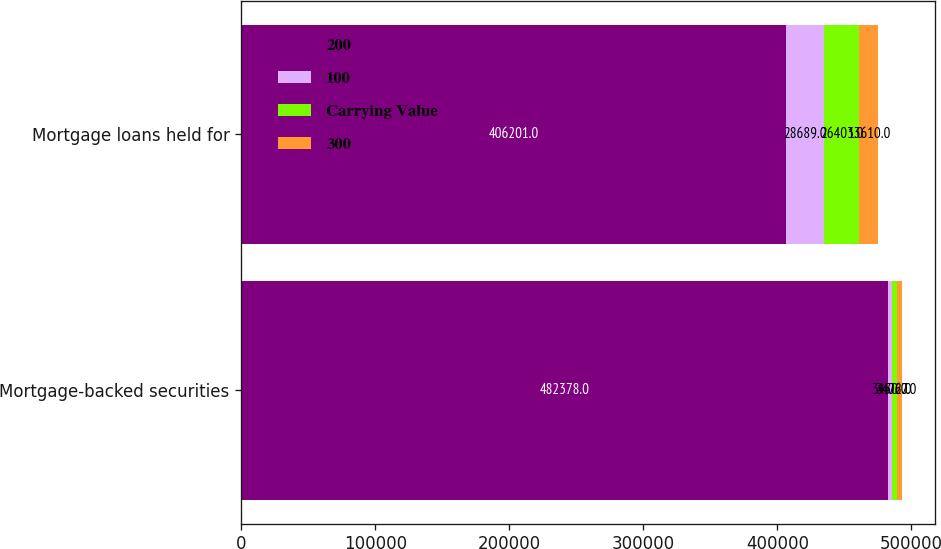Convert chart to OTSL. <chart><loc_0><loc_0><loc_500><loc_500><stacked_bar_chart><ecel><fcel>Mortgage-backed securities<fcel>Mortgage loans held for<nl><fcel>200<fcel>482378<fcel>406201<nl><fcel>100<fcel>3450<fcel>28689<nl><fcel>Carrying Value<fcel>3472<fcel>26403<nl><fcel>300<fcel>4067<fcel>13610<nl></chart> 